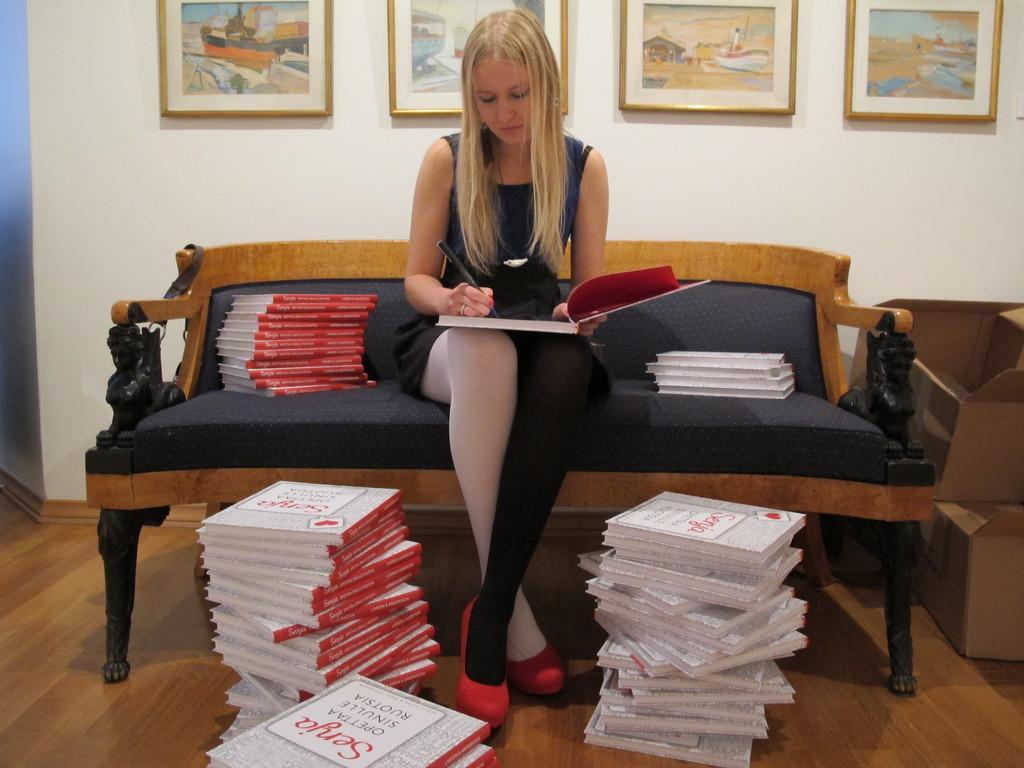Describe this image in one or two sentences. In the picture we can see a woman sitting on the bench and writing something in the book, she is in a black dress and besides her we can see the bundle of books and on the floor also we can see some bundle of books and in the background we can see a wall with some photo frames and paintings on it. 